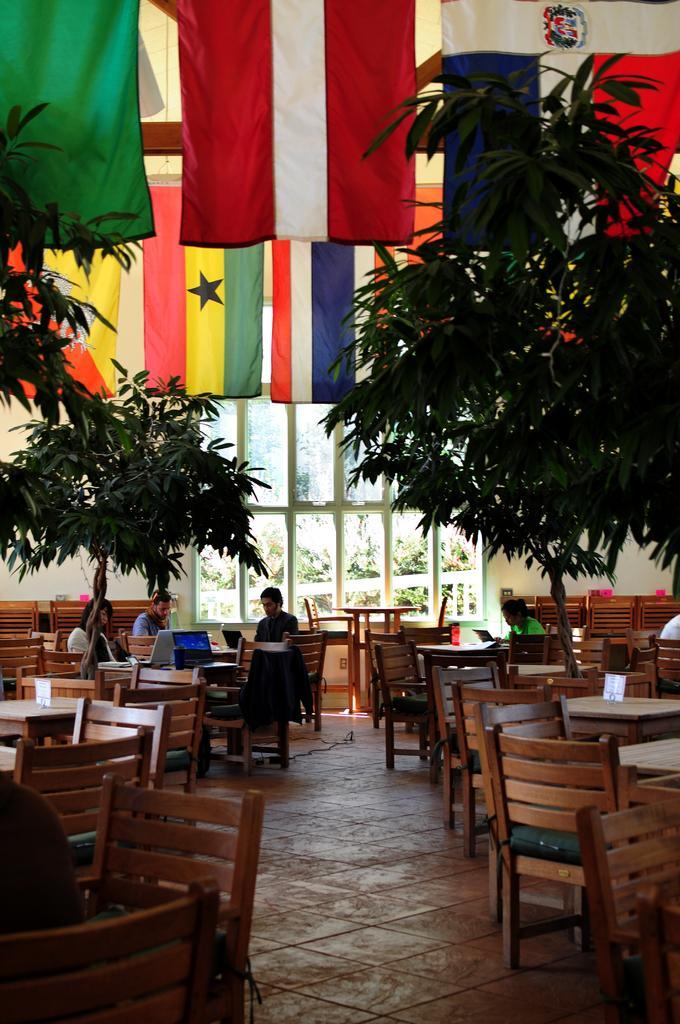How would you summarize this image in a sentence or two? there is a restaurant in which there are many tables and chairs some people sitting there and working with their laptops in front of them,here we can also see some trees ,there are some flags. 